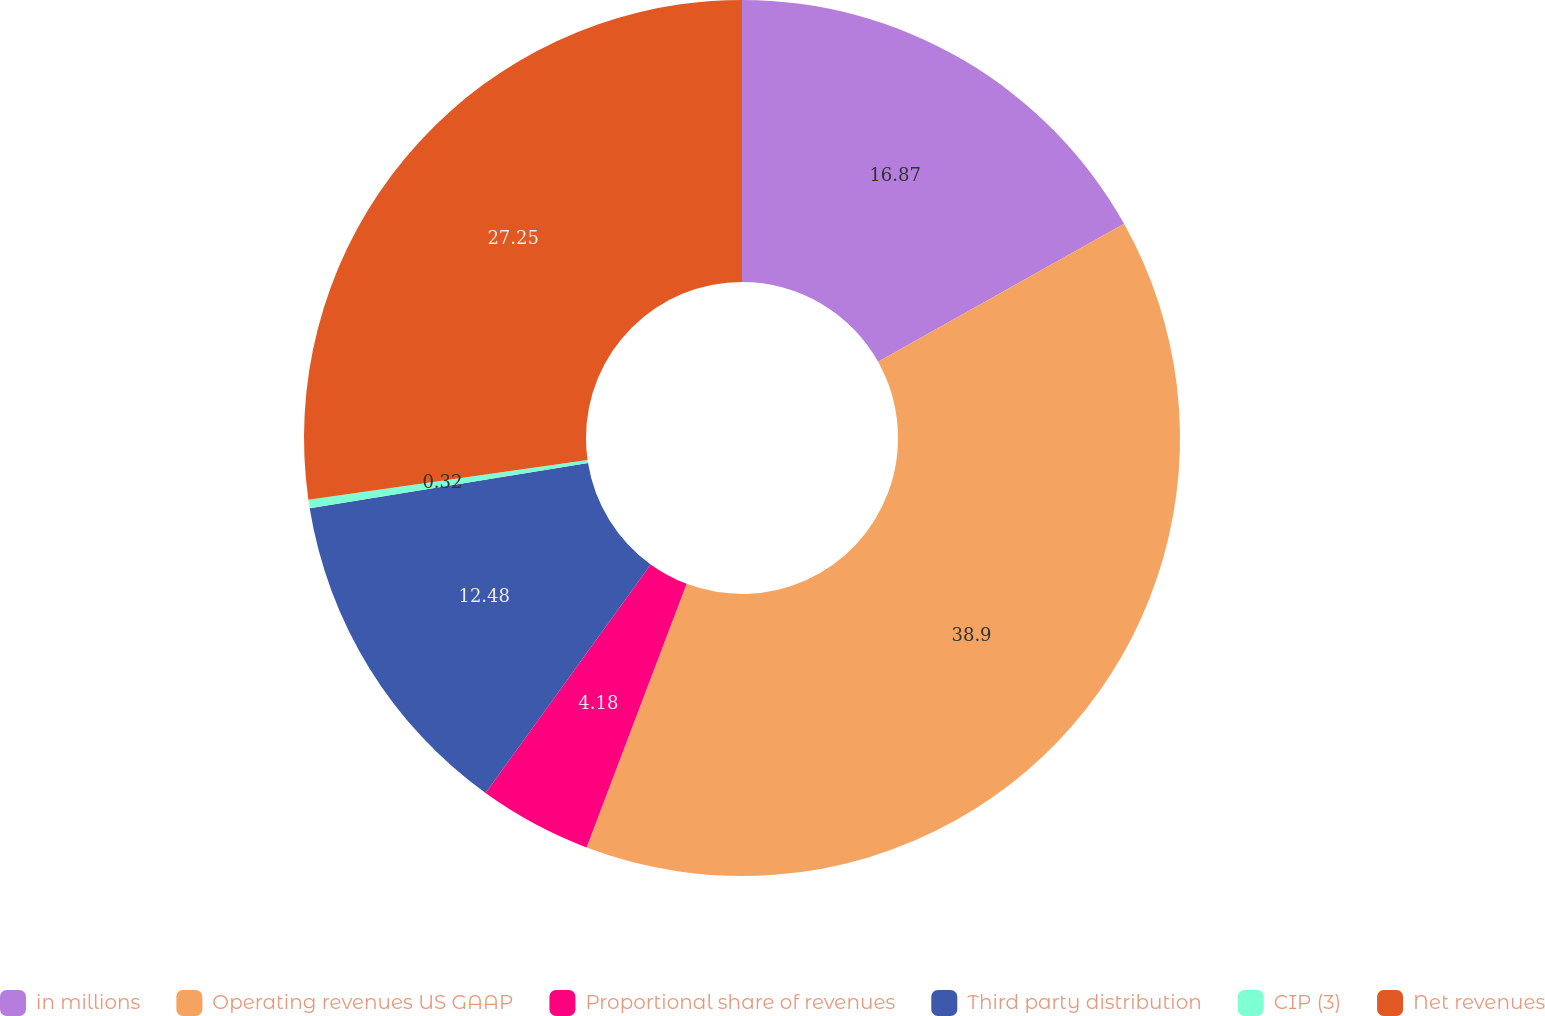Convert chart to OTSL. <chart><loc_0><loc_0><loc_500><loc_500><pie_chart><fcel>in millions<fcel>Operating revenues US GAAP<fcel>Proportional share of revenues<fcel>Third party distribution<fcel>CIP (3)<fcel>Net revenues<nl><fcel>16.87%<fcel>38.91%<fcel>4.18%<fcel>12.48%<fcel>0.32%<fcel>27.25%<nl></chart> 